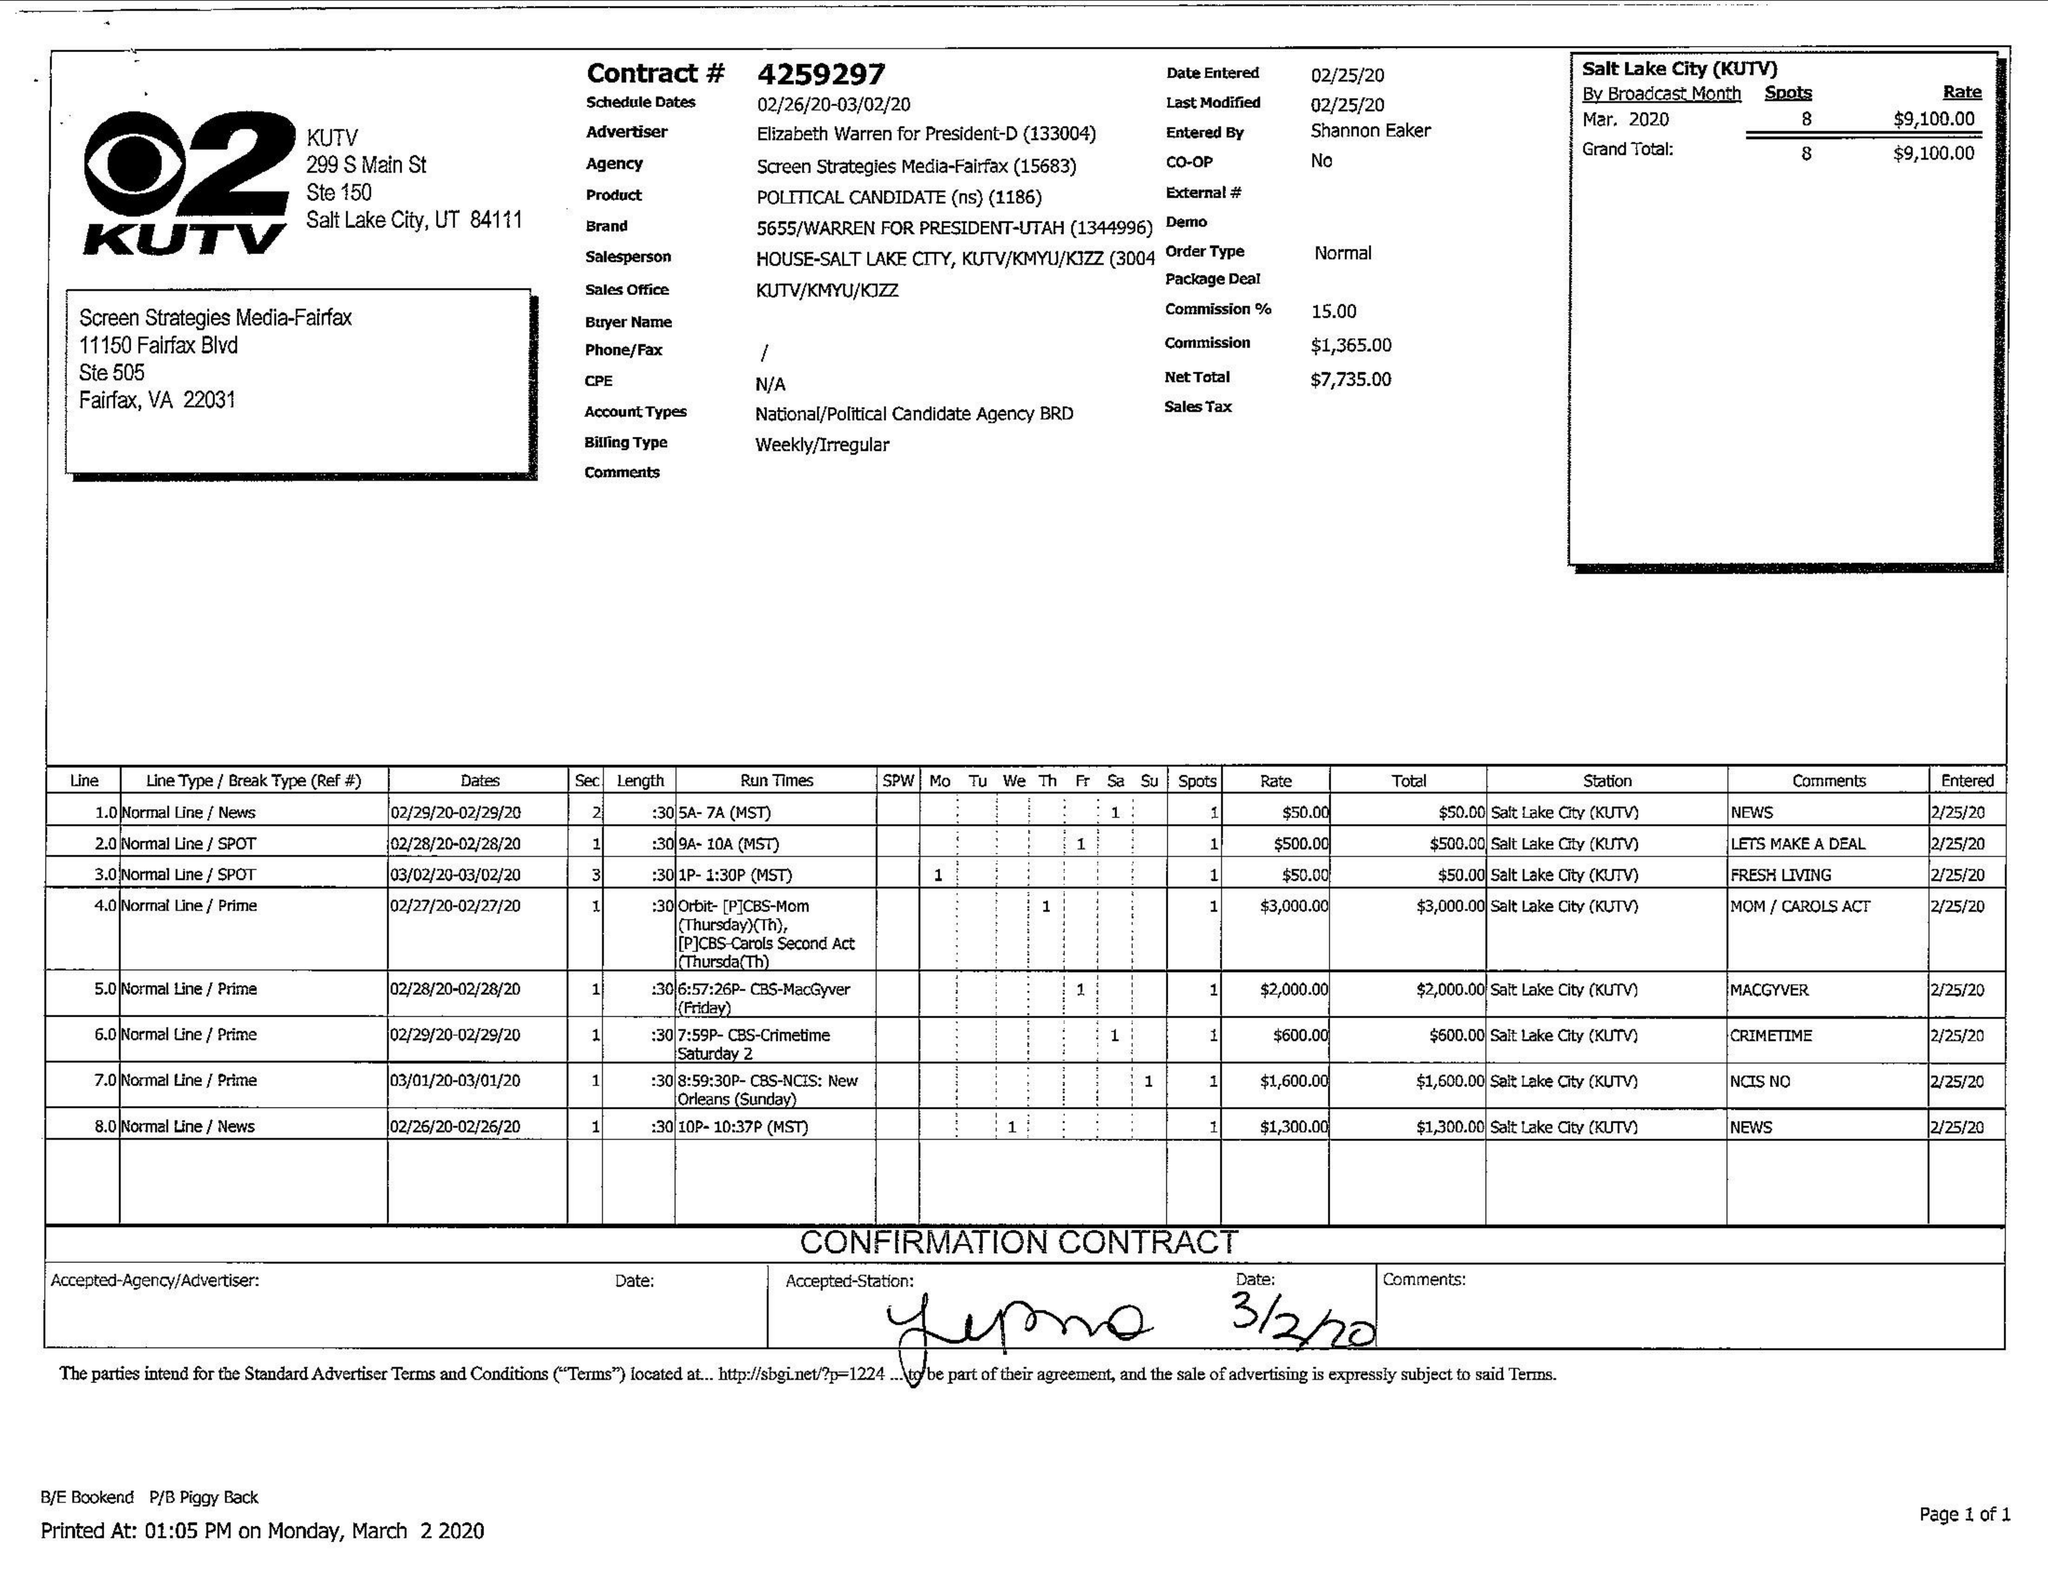What is the value for the gross_amount?
Answer the question using a single word or phrase. 9100.00 